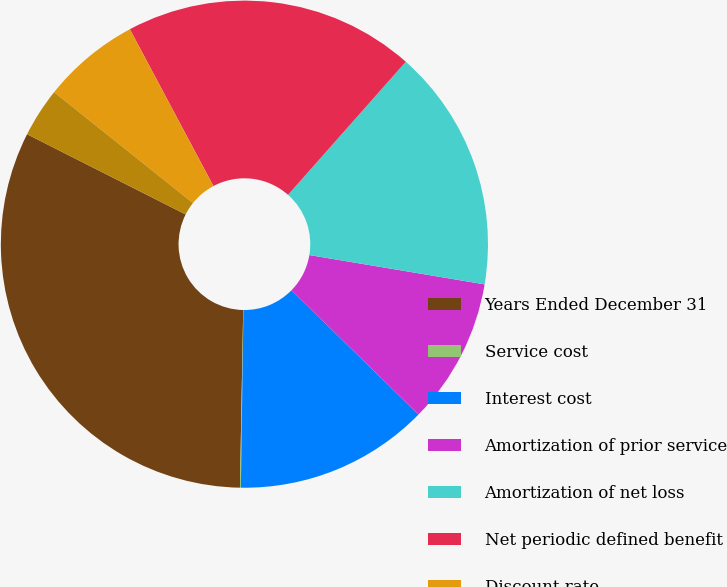Convert chart to OTSL. <chart><loc_0><loc_0><loc_500><loc_500><pie_chart><fcel>Years Ended December 31<fcel>Service cost<fcel>Interest cost<fcel>Amortization of prior service<fcel>Amortization of net loss<fcel>Net periodic defined benefit<fcel>Discount rate<fcel>Rate of compensation increase<nl><fcel>32.16%<fcel>0.06%<fcel>12.9%<fcel>9.69%<fcel>16.11%<fcel>19.32%<fcel>6.48%<fcel>3.27%<nl></chart> 